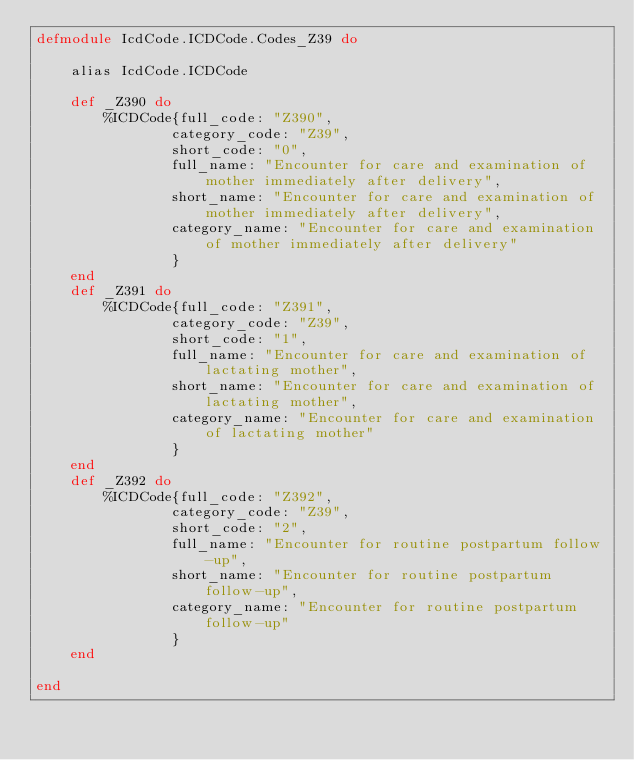<code> <loc_0><loc_0><loc_500><loc_500><_Elixir_>defmodule IcdCode.ICDCode.Codes_Z39 do

	alias IcdCode.ICDCode

	def _Z390 do 
		%ICDCode{full_code: "Z390",
        		category_code: "Z39",
        		short_code: "0",
        		full_name: "Encounter for care and examination of mother immediately after delivery",
        		short_name: "Encounter for care and examination of mother immediately after delivery",
        		category_name: "Encounter for care and examination of mother immediately after delivery"
        		}
	end
	def _Z391 do 
		%ICDCode{full_code: "Z391",
        		category_code: "Z39",
        		short_code: "1",
        		full_name: "Encounter for care and examination of lactating mother",
        		short_name: "Encounter for care and examination of lactating mother",
        		category_name: "Encounter for care and examination of lactating mother"
        		}
	end
	def _Z392 do 
		%ICDCode{full_code: "Z392",
        		category_code: "Z39",
        		short_code: "2",
        		full_name: "Encounter for routine postpartum follow-up",
        		short_name: "Encounter for routine postpartum follow-up",
        		category_name: "Encounter for routine postpartum follow-up"
        		}
	end

end
</code> 